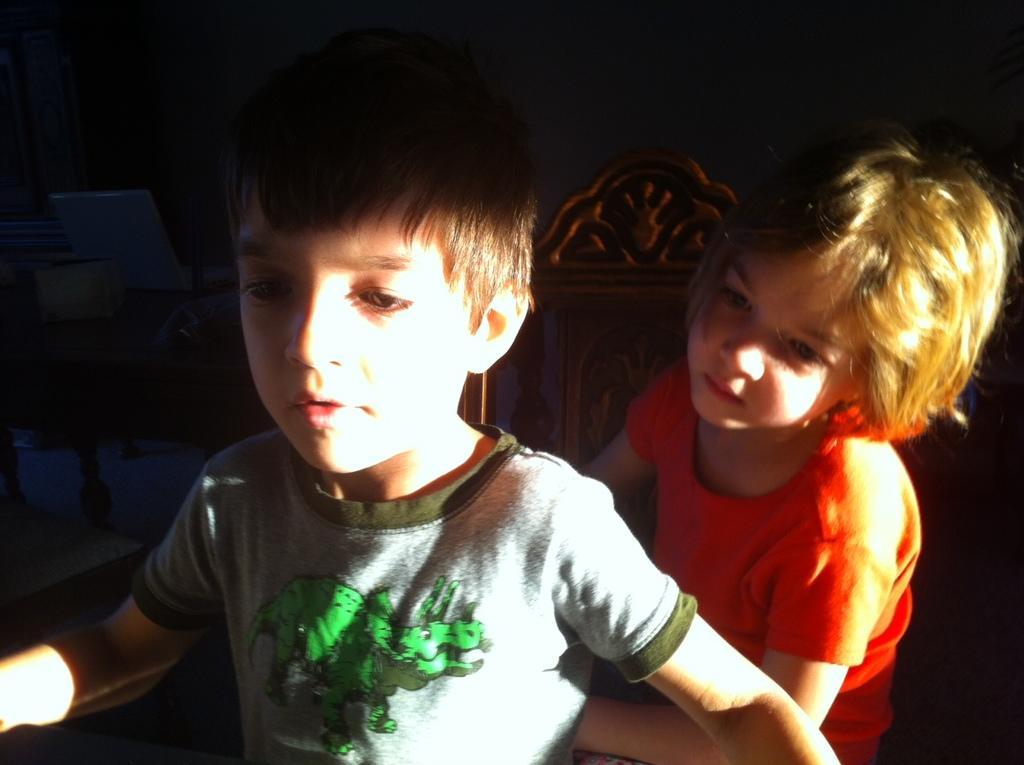In one or two sentences, can you explain what this image depicts? In this image we can see two children. In the back there is a wooden object. In the background it is dark. 